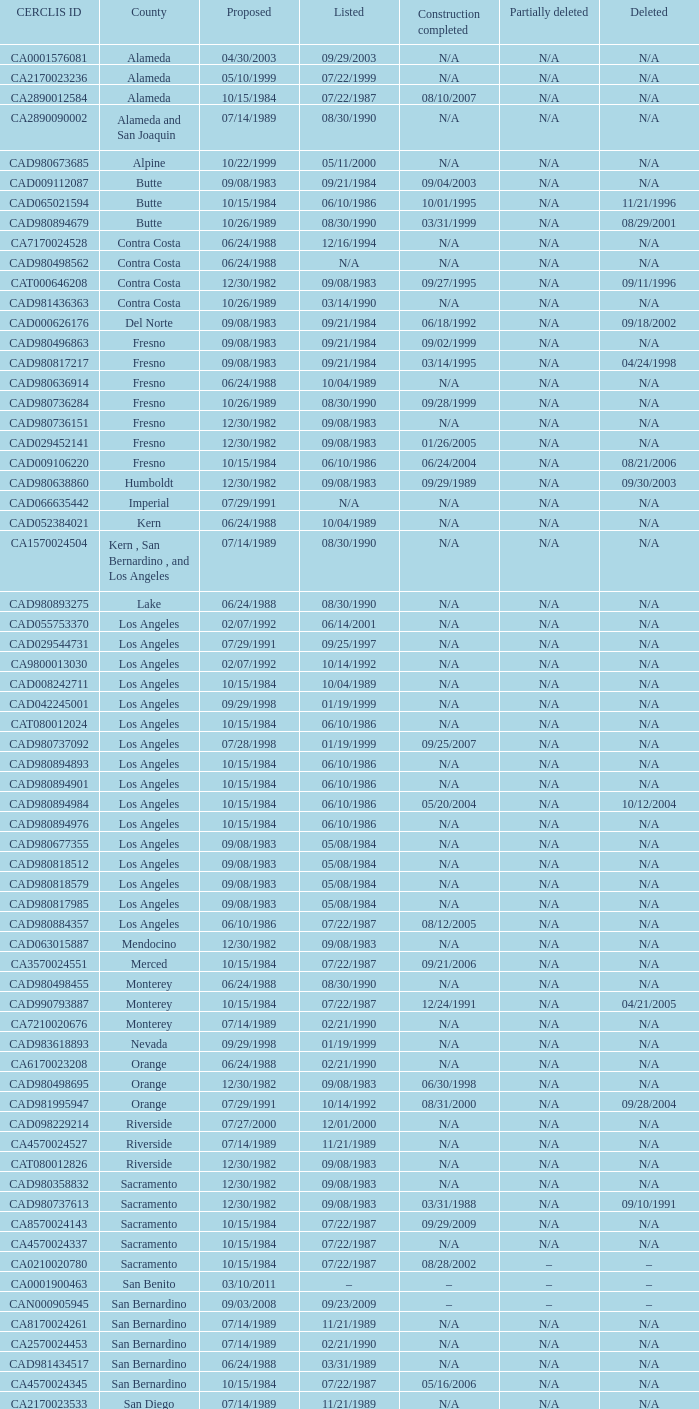I'm looking to parse the entire table for insights. Could you assist me with that? {'header': ['CERCLIS ID', 'County', 'Proposed', 'Listed', 'Construction completed', 'Partially deleted', 'Deleted'], 'rows': [['CA0001576081', 'Alameda', '04/30/2003', '09/29/2003', 'N/A', 'N/A', 'N/A'], ['CA2170023236', 'Alameda', '05/10/1999', '07/22/1999', 'N/A', 'N/A', 'N/A'], ['CA2890012584', 'Alameda', '10/15/1984', '07/22/1987', '08/10/2007', 'N/A', 'N/A'], ['CA2890090002', 'Alameda and San Joaquin', '07/14/1989', '08/30/1990', 'N/A', 'N/A', 'N/A'], ['CAD980673685', 'Alpine', '10/22/1999', '05/11/2000', 'N/A', 'N/A', 'N/A'], ['CAD009112087', 'Butte', '09/08/1983', '09/21/1984', '09/04/2003', 'N/A', 'N/A'], ['CAD065021594', 'Butte', '10/15/1984', '06/10/1986', '10/01/1995', 'N/A', '11/21/1996'], ['CAD980894679', 'Butte', '10/26/1989', '08/30/1990', '03/31/1999', 'N/A', '08/29/2001'], ['CA7170024528', 'Contra Costa', '06/24/1988', '12/16/1994', 'N/A', 'N/A', 'N/A'], ['CAD980498562', 'Contra Costa', '06/24/1988', 'N/A', 'N/A', 'N/A', 'N/A'], ['CAT000646208', 'Contra Costa', '12/30/1982', '09/08/1983', '09/27/1995', 'N/A', '09/11/1996'], ['CAD981436363', 'Contra Costa', '10/26/1989', '03/14/1990', 'N/A', 'N/A', 'N/A'], ['CAD000626176', 'Del Norte', '09/08/1983', '09/21/1984', '06/18/1992', 'N/A', '09/18/2002'], ['CAD980496863', 'Fresno', '09/08/1983', '09/21/1984', '09/02/1999', 'N/A', 'N/A'], ['CAD980817217', 'Fresno', '09/08/1983', '09/21/1984', '03/14/1995', 'N/A', '04/24/1998'], ['CAD980636914', 'Fresno', '06/24/1988', '10/04/1989', 'N/A', 'N/A', 'N/A'], ['CAD980736284', 'Fresno', '10/26/1989', '08/30/1990', '09/28/1999', 'N/A', 'N/A'], ['CAD980736151', 'Fresno', '12/30/1982', '09/08/1983', 'N/A', 'N/A', 'N/A'], ['CAD029452141', 'Fresno', '12/30/1982', '09/08/1983', '01/26/2005', 'N/A', 'N/A'], ['CAD009106220', 'Fresno', '10/15/1984', '06/10/1986', '06/24/2004', 'N/A', '08/21/2006'], ['CAD980638860', 'Humboldt', '12/30/1982', '09/08/1983', '09/29/1989', 'N/A', '09/30/2003'], ['CAD066635442', 'Imperial', '07/29/1991', 'N/A', 'N/A', 'N/A', 'N/A'], ['CAD052384021', 'Kern', '06/24/1988', '10/04/1989', 'N/A', 'N/A', 'N/A'], ['CA1570024504', 'Kern , San Bernardino , and Los Angeles', '07/14/1989', '08/30/1990', 'N/A', 'N/A', 'N/A'], ['CAD980893275', 'Lake', '06/24/1988', '08/30/1990', 'N/A', 'N/A', 'N/A'], ['CAD055753370', 'Los Angeles', '02/07/1992', '06/14/2001', 'N/A', 'N/A', 'N/A'], ['CAD029544731', 'Los Angeles', '07/29/1991', '09/25/1997', 'N/A', 'N/A', 'N/A'], ['CA9800013030', 'Los Angeles', '02/07/1992', '10/14/1992', 'N/A', 'N/A', 'N/A'], ['CAD008242711', 'Los Angeles', '10/15/1984', '10/04/1989', 'N/A', 'N/A', 'N/A'], ['CAD042245001', 'Los Angeles', '09/29/1998', '01/19/1999', 'N/A', 'N/A', 'N/A'], ['CAT080012024', 'Los Angeles', '10/15/1984', '06/10/1986', 'N/A', 'N/A', 'N/A'], ['CAD980737092', 'Los Angeles', '07/28/1998', '01/19/1999', '09/25/2007', 'N/A', 'N/A'], ['CAD980894893', 'Los Angeles', '10/15/1984', '06/10/1986', 'N/A', 'N/A', 'N/A'], ['CAD980894901', 'Los Angeles', '10/15/1984', '06/10/1986', 'N/A', 'N/A', 'N/A'], ['CAD980894984', 'Los Angeles', '10/15/1984', '06/10/1986', '05/20/2004', 'N/A', '10/12/2004'], ['CAD980894976', 'Los Angeles', '10/15/1984', '06/10/1986', 'N/A', 'N/A', 'N/A'], ['CAD980677355', 'Los Angeles', '09/08/1983', '05/08/1984', 'N/A', 'N/A', 'N/A'], ['CAD980818512', 'Los Angeles', '09/08/1983', '05/08/1984', 'N/A', 'N/A', 'N/A'], ['CAD980818579', 'Los Angeles', '09/08/1983', '05/08/1984', 'N/A', 'N/A', 'N/A'], ['CAD980817985', 'Los Angeles', '09/08/1983', '05/08/1984', 'N/A', 'N/A', 'N/A'], ['CAD980884357', 'Los Angeles', '06/10/1986', '07/22/1987', '08/12/2005', 'N/A', 'N/A'], ['CAD063015887', 'Mendocino', '12/30/1982', '09/08/1983', 'N/A', 'N/A', 'N/A'], ['CA3570024551', 'Merced', '10/15/1984', '07/22/1987', '09/21/2006', 'N/A', 'N/A'], ['CAD980498455', 'Monterey', '06/24/1988', '08/30/1990', 'N/A', 'N/A', 'N/A'], ['CAD990793887', 'Monterey', '10/15/1984', '07/22/1987', '12/24/1991', 'N/A', '04/21/2005'], ['CA7210020676', 'Monterey', '07/14/1989', '02/21/1990', 'N/A', 'N/A', 'N/A'], ['CAD983618893', 'Nevada', '09/29/1998', '01/19/1999', 'N/A', 'N/A', 'N/A'], ['CA6170023208', 'Orange', '06/24/1988', '02/21/1990', 'N/A', 'N/A', 'N/A'], ['CAD980498695', 'Orange', '12/30/1982', '09/08/1983', '06/30/1998', 'N/A', 'N/A'], ['CAD981995947', 'Orange', '07/29/1991', '10/14/1992', '08/31/2000', 'N/A', '09/28/2004'], ['CAD098229214', 'Riverside', '07/27/2000', '12/01/2000', 'N/A', 'N/A', 'N/A'], ['CA4570024527', 'Riverside', '07/14/1989', '11/21/1989', 'N/A', 'N/A', 'N/A'], ['CAT080012826', 'Riverside', '12/30/1982', '09/08/1983', 'N/A', 'N/A', 'N/A'], ['CAD980358832', 'Sacramento', '12/30/1982', '09/08/1983', 'N/A', 'N/A', 'N/A'], ['CAD980737613', 'Sacramento', '12/30/1982', '09/08/1983', '03/31/1988', 'N/A', '09/10/1991'], ['CA8570024143', 'Sacramento', '10/15/1984', '07/22/1987', '09/29/2009', 'N/A', 'N/A'], ['CA4570024337', 'Sacramento', '10/15/1984', '07/22/1987', 'N/A', 'N/A', 'N/A'], ['CA0210020780', 'Sacramento', '10/15/1984', '07/22/1987', '08/28/2002', '–', '–'], ['CA0001900463', 'San Benito', '03/10/2011', '–', '–', '–', '–'], ['CAN000905945', 'San Bernardino', '09/03/2008', '09/23/2009', '–', '–', '–'], ['CA8170024261', 'San Bernardino', '07/14/1989', '11/21/1989', 'N/A', 'N/A', 'N/A'], ['CA2570024453', 'San Bernardino', '07/14/1989', '02/21/1990', 'N/A', 'N/A', 'N/A'], ['CAD981434517', 'San Bernardino', '06/24/1988', '03/31/1989', 'N/A', 'N/A', 'N/A'], ['CA4570024345', 'San Bernardino', '10/15/1984', '07/22/1987', '05/16/2006', 'N/A', 'N/A'], ['CA2170023533', 'San Diego', '07/14/1989', '11/21/1989', 'N/A', 'N/A', 'N/A'], ['CA1170090087', 'San Francisco', '07/14/1989', '11/21/1989', 'N/A', '04/05/1999', 'N/A'], ['CAD009106527', 'San Joaquin', '02/07/1992', '10/14/1992', 'N/A', 'N/A', 'N/A'], ['CA8210020832', 'San Joaquin', '10/15/1984', '07/22/1987', '06/27/2003', 'N/A', 'N/A'], ['CA4971520834', 'San Joaquin', '07/14/1989', '08/30/1990', 'N/A', 'N/A', 'N/A'], ['CA1141190578', 'San Luis Obispo', '09/23/2004', '04/19/2006', 'N/A', 'N/A', 'N/A'], ['CAD020748125', 'Santa Barbara', '06/14/2001', '09/13/2001', 'N/A', 'N/A', 'N/A'], ['CAD048634059', 'Santa Clara', '10/15/1984', '06/10/1986', '09/17/1993', 'N/A', 'N/A'], ['CAT080034234', 'Santa Clara', '06/24/1988', '08/30/1990', '03/25/1992', 'N/A', 'N/A'], ['CAD042728840', 'Santa Clara', '10/15/1984', '07/22/1987', '09/27/1993', 'N/A', 'N/A'], ['CAD009212838', 'Santa Clara', '06/24/1988', '02/21/1990', '03/31/1992', 'N/A', 'N/A'], ['CAD095989778', 'Santa Clara', '10/15/1984', '02/11/1991', '08/24/1999', 'N/A', 'N/A'], ['CAD097012298', 'Santa Clara', '10/15/1984', '10/04/1989', '03/25/1992', 'N/A', 'N/A'], ['CAD980884209', 'Santa Clara', '06/24/1988', '02/21/1990', '09/16/1997', 'N/A', 'N/A'], ['CAD061620217', 'Santa Clara', '10/15/1984', '06/10/1986', '08/24/1999', 'N/A', 'N/A'], ['CAT000612184', 'Santa Clara', '10/15/1984', '06/10/1986', '08/18/1992', 'N/A', 'N/A'], ['CAD092212497', 'Santa Clara', '10/15/1984', '06/10/1986', '08/19/1992', 'N/A', 'N/A'], ['CAD041472341', 'Santa Clara', '06/24/1988', '08/30/1990', '09/08/1992', 'N/A', 'N/A'], ['CAD009103318', 'Santa Clara', '06/24/1988', '10/04/1989', '09/20/2002', 'N/A', 'N/A'], ['CAD029295706', 'Santa Clara', '10/15/1984', '10/04/1989', '09/29/1998', 'N/A', 'N/A'], ['CA2170090078', 'Santa Clara', '04/10/1985', '07/22/1987', 'N/A', 'N/A', 'N/A'], ['CAD049236201', 'Santa Clara', '10/15/1984', '07/22/1987', '08/22/1994', 'N/A', 'N/A'], ['CAD041472986', 'Santa Clara', '10/15/1984', '07/22/1987', '10/16/1997', 'N/A', 'N/A'], ['CAD009205097', 'Santa Clara', '10/15/1984', '06/10/1986', '08/24/1999', 'N/A', 'N/A'], ['CAD980894885', 'Santa Clara', '10/15/1984', '06/10/1986', '09/23/1998', 'N/A', 'N/A'], ['CAD009138488', 'Santa Clara', '06/24/1988', '02/11/1991', '09/16/1992', 'N/A', 'N/A'], ['CAD990832735', 'Santa Clara', '06/24/1988', '10/04/1989', '03/25/1992', 'N/A', 'N/A'], ['CAD009159088', 'Santa Clara', '06/24/1988', '02/21/1990', '09/17/1993', 'N/A', 'N/A'], ['CAD009111444', 'Santa Clara', '10/15/1984', '07/22/1987', '03/31/1992', 'N/A', 'N/A'], ['CAD001864081', 'Santa Clara', '10/15/1984', '06/10/1986', '09/27/2000', 'N/A', 'N/A'], ['CAD980893234', 'Santa Cruz', '01/22/1987', '08/30/1990', '09/22/1994', 'N/A', 'N/A'], ['CAD980498612', 'Shasta', '12/30/1982', '09/08/1983', 'N/A', 'N/A', 'N/A'], ['CAN000906063', 'Siskiyou', '03/10/2011', '–', '–', '–', '–'], ['CAD000625731', 'Siskiyou', '10/15/1984', '10/04/1989', '09/14/2001', 'N/A', 'N/A'], ['CA2890190000', 'Solano', '01/18/1994', '05/31/1994', 'N/A', 'N/A', 'N/A'], ['CA5570024575', 'Solano', '07/14/1989', '11/21/1989', 'N/A', 'N/A', 'N/A'], ['CAD000074120', 'Sonoma', '12/30/1982', '09/08/1983', '09/09/1994', 'N/A', 'N/A'], ['CAD981171523', 'Sonoma', '06/24/1988', '02/21/1990', '08/14/1992', 'N/A', 'N/A'], ['CAD981997752', 'Stanislaus', '06/24/1988', '03/31/1989', 'N/A', 'N/A', 'N/A'], ['CA7210020759', 'Stanislaus', '06/24/1988', '02/21/1990', '09/30/1997', 'N/A', 'N/A'], ['CAD063020143', 'Stanislaus', '06/24/1988', '03/31/1989', '08/21/2008', 'N/A', 'N/A'], ['CAD048645444', 'Tulare', '10/15/1984', '06/10/1986', '09/21/1993', 'N/A', 'N/A'], ['CAD980816466', 'Tulare', '01/22/1987', '03/31/1989', '09/25/2001', 'N/A', '09/25/2009'], ['CAD009688052', 'Ventura', '03/07/2007', '09/19/2007', 'N/A', 'N/A', 'N/A'], ['CAD980636781', 'Ventura', '06/24/1988', '10/04/1989', '09/27/1996', 'N/A', 'N/A'], ['CAD071530380', 'Yolo', '01/18/1994', '05/31/1994', 'N/A', 'N/A', 'N/A']]} On august 10, 2007, what construction work reached its completion? 07/22/1987. 